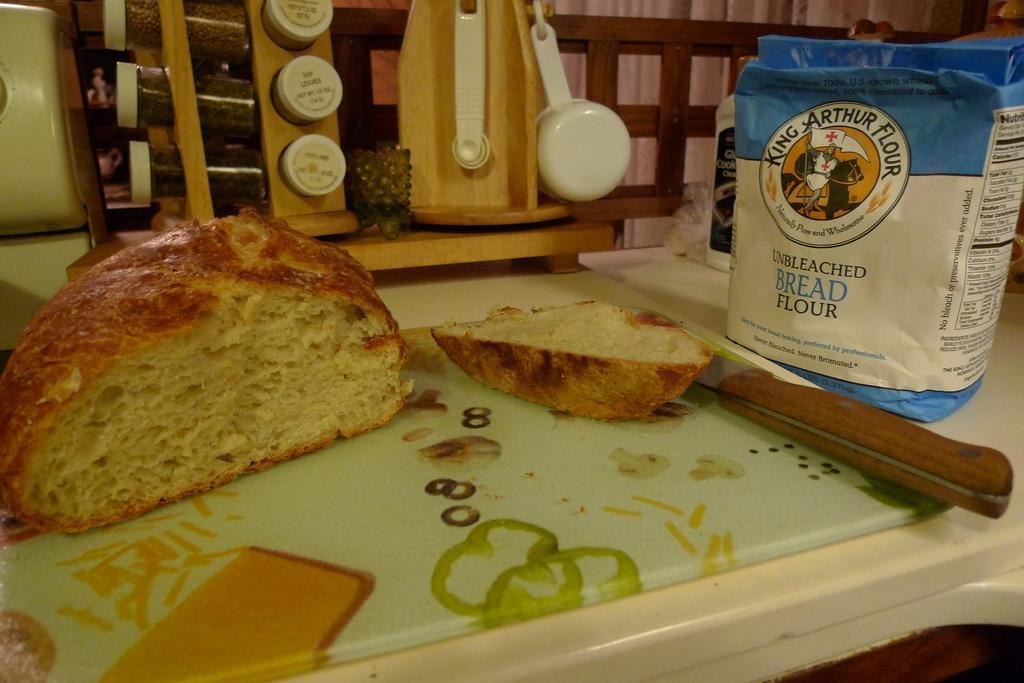In one or two sentences, can you explain what this image depicts? In this image we can see bread pieces and knife on a chopping on the table and we can also see a packet, bottle and on a stand we can see jars and spoon. In the background we can see wooden object and a cloth. 